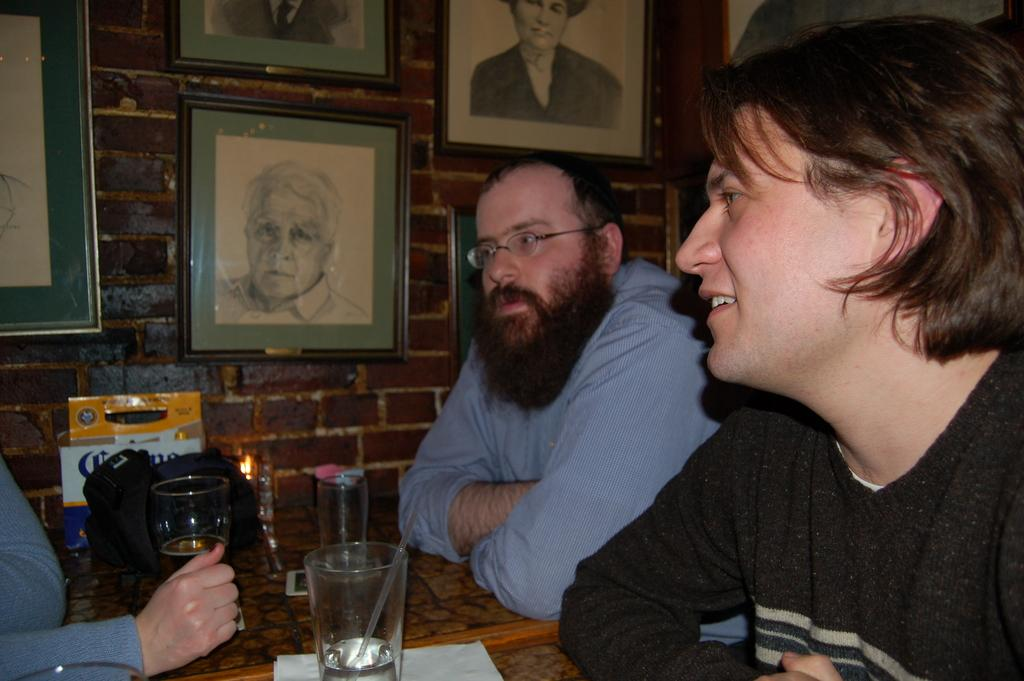What are the people in the image doing? There are persons sitting at the table in the image. What objects can be seen on the table? There are glasses, a bag, a mobile phone, and tissues on the table. What is visible in the background of the image? There is a wall and photo frames in the background. What type of plants can be seen growing on the mobile phone in the image? There are no plants visible on the mobile phone in the image. What kind of ray is emitted from the bag on the table? There is no ray emitted from the bag on the table in the image. 